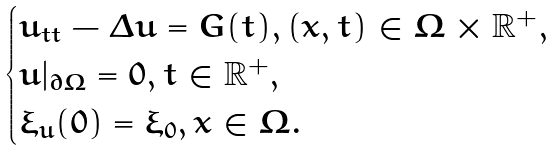<formula> <loc_0><loc_0><loc_500><loc_500>\begin{cases} u _ { t t } - \Delta u = G ( t ) , ( x , t ) \in \Omega \times \mathbb { R } ^ { + } , \\ u | _ { \partial \Omega } = 0 , t \in \mathbb { R } ^ { + } , \\ \xi _ { u } ( 0 ) = \xi _ { 0 } , x \in \Omega . \end{cases}</formula> 